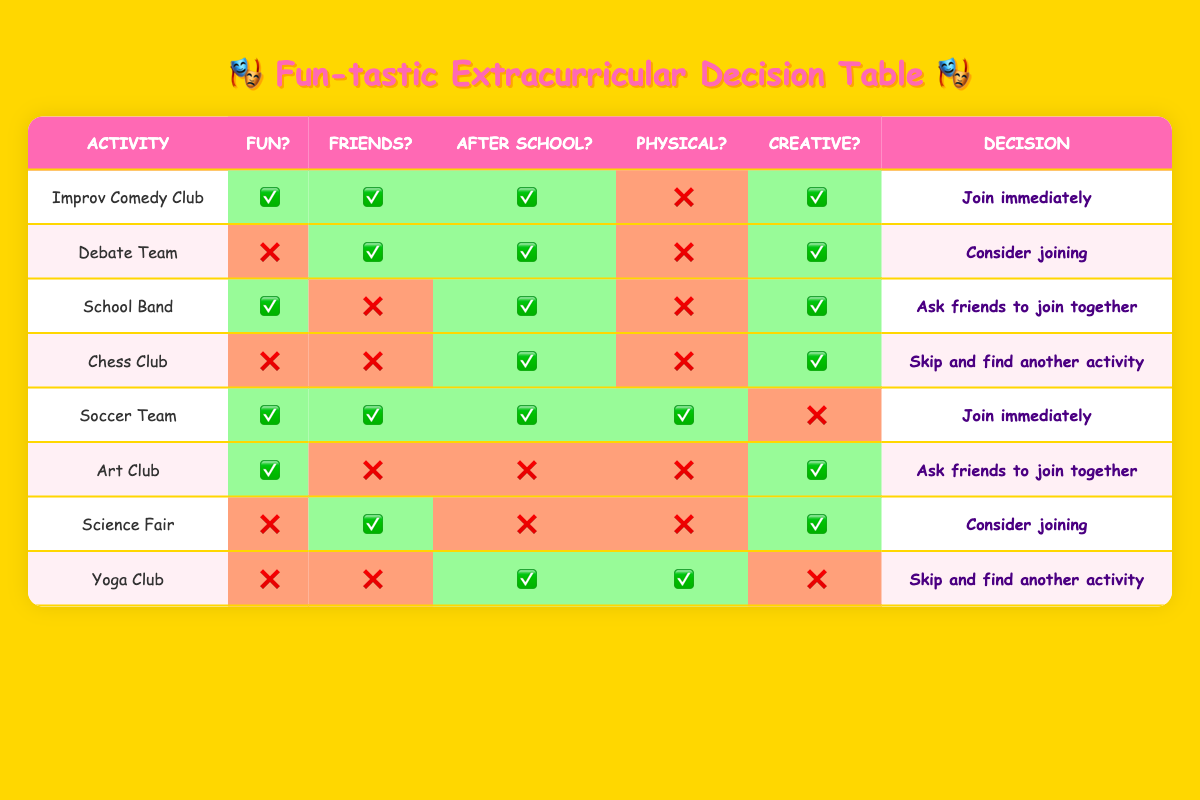What's the decision for the "Improv Comedy Club"? The conditions for "Improv Comedy Club" are that it is fun, friends are participating, it meets after school, it does not require physical effort, and it involves creativity. Since the action stated is "Join immediately," this is the decision for this activity.
Answer: Join immediately How many activities require physical effort? The activities that require physical effort are "Soccer Team" and "Yoga Club", totaling 2 activities.
Answer: 2 Is the "Debate Team" a fun activity? According to the table, the condition for fun for the "Debate Team" is false, meaning it is not considered fun.
Answer: No Which activity has the same decision as "Science Fair"? The "Science Fair" activity has the action "Consider joining". The "Debate Team" also has the same action, making them both share that decision.
Answer: Debate Team What is the decision for the activity that involves both creativity and is fun? The "Art Club" is fun and involves creativity. The decision based on the table is "Ask friends to join together."
Answer: Ask friends to join together Which activities involve friends participating and are fun? Count them. The "Improv Comedy Club" and "Soccer Team" both fit this description. Therefore, there are a total of 2 activities that are fun and have friends participating.
Answer: 2 If I want to skip an activity, which one would I consider first based on the rules? "Yoga Club" and "Chess Club" have the action "Skip and find another activity", but "Chess Club" meets after school, so if focusing on that, I would skip "Chess Club" first because it is less attractive in conditions. Thus, I would consider "Chess Club" first.
Answer: Chess Club In how many activities friends are not participating? The "School Band," "Chess Club," "Art Club," and "Yoga Club" have the condition where no friends are participating, totaling 4 activities.
Answer: 4 